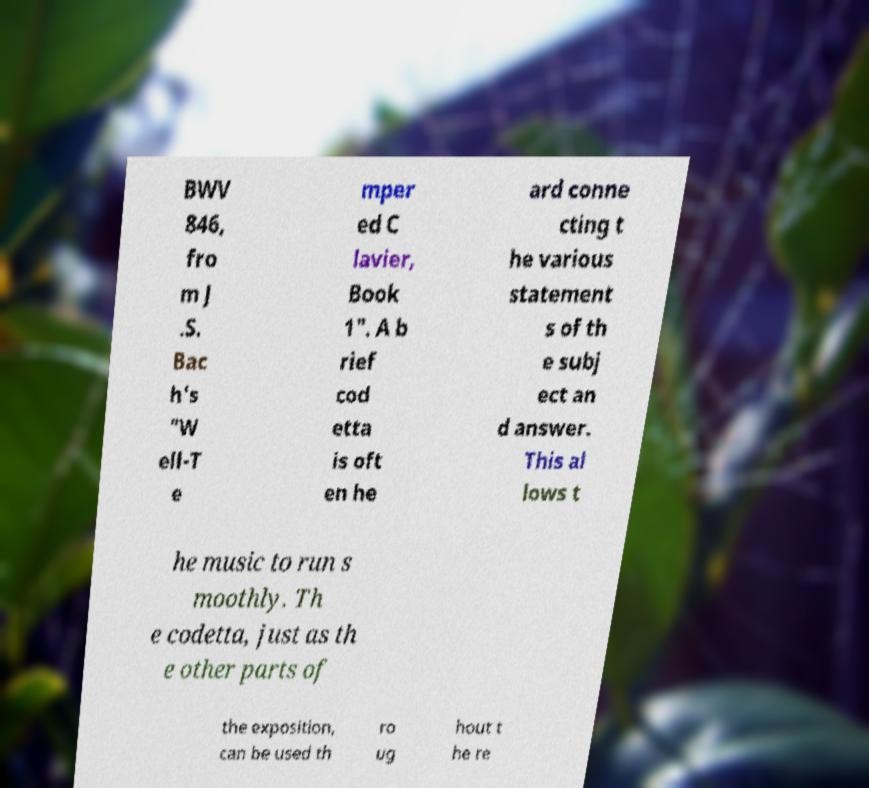Could you extract and type out the text from this image? BWV 846, fro m J .S. Bac h's "W ell-T e mper ed C lavier, Book 1". A b rief cod etta is oft en he ard conne cting t he various statement s of th e subj ect an d answer. This al lows t he music to run s moothly. Th e codetta, just as th e other parts of the exposition, can be used th ro ug hout t he re 